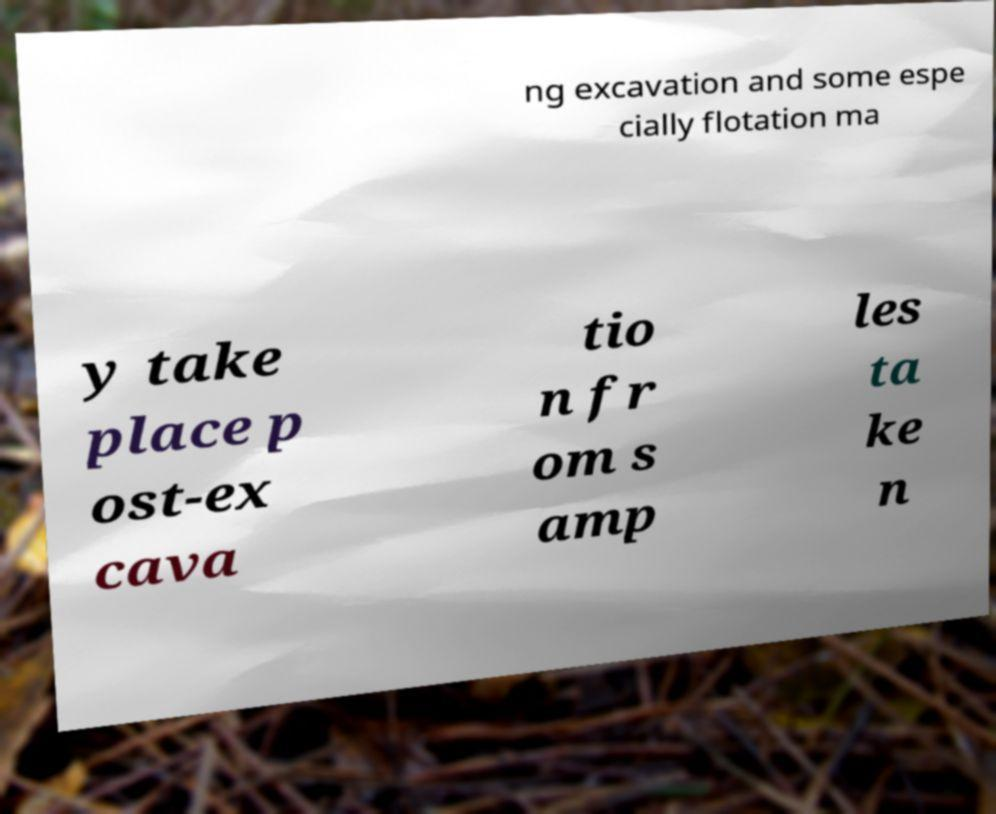Please read and relay the text visible in this image. What does it say? ng excavation and some espe cially flotation ma y take place p ost-ex cava tio n fr om s amp les ta ke n 